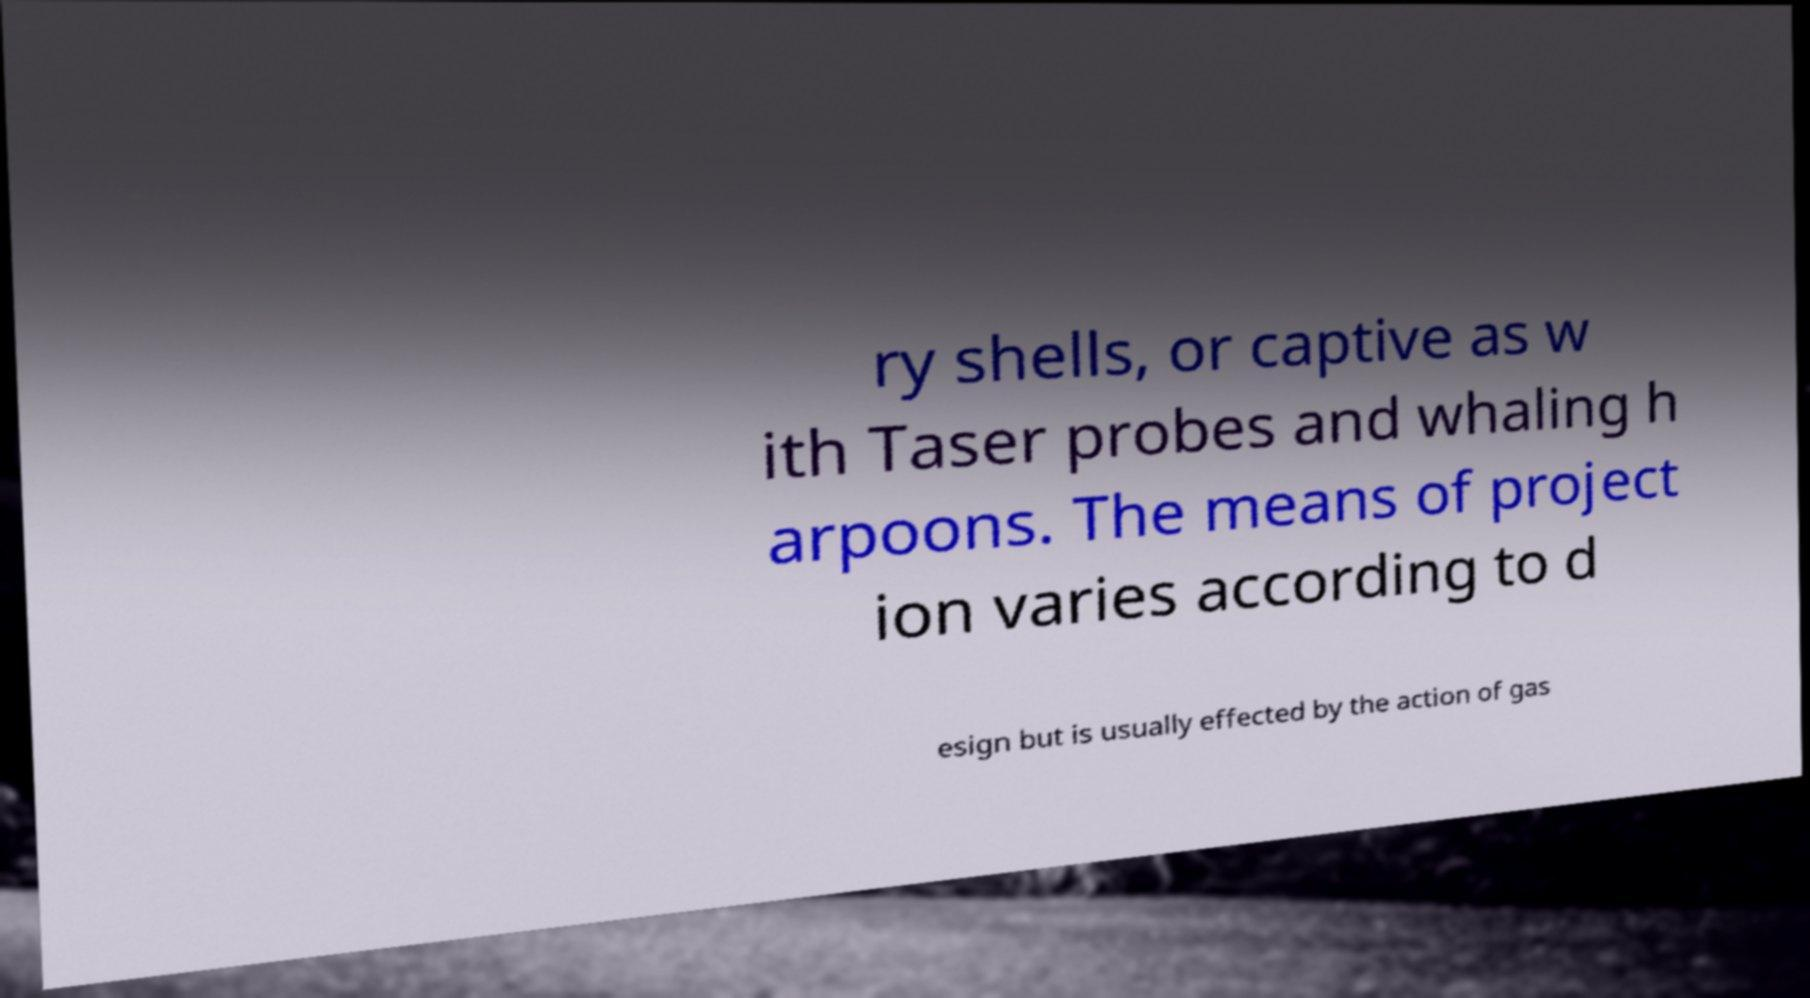Could you assist in decoding the text presented in this image and type it out clearly? ry shells, or captive as w ith Taser probes and whaling h arpoons. The means of project ion varies according to d esign but is usually effected by the action of gas 